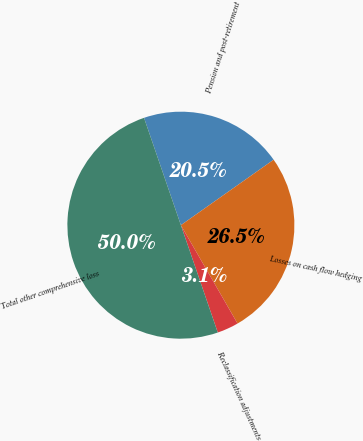Convert chart. <chart><loc_0><loc_0><loc_500><loc_500><pie_chart><fcel>Pension and post-retirement<fcel>Losses on cash flow hedging<fcel>Reclassification adjustments<fcel>Total other comprehensive loss<nl><fcel>20.48%<fcel>26.46%<fcel>3.05%<fcel>50.0%<nl></chart> 